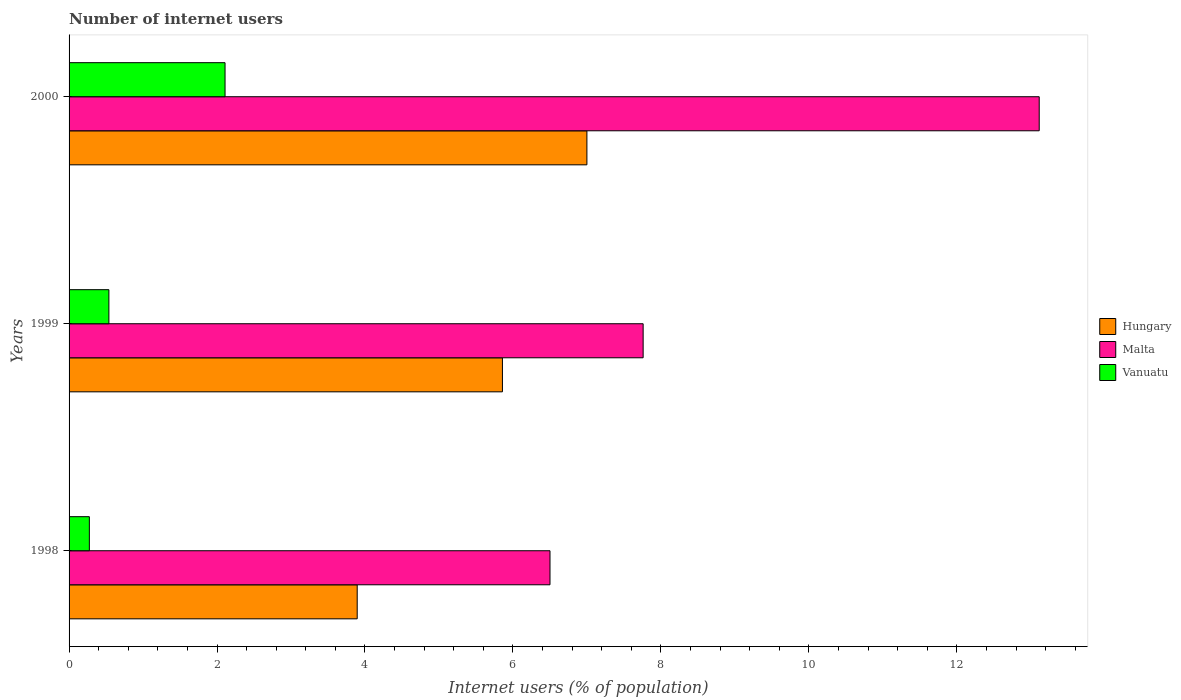How many different coloured bars are there?
Your answer should be very brief. 3. How many groups of bars are there?
Provide a succinct answer. 3. Are the number of bars per tick equal to the number of legend labels?
Give a very brief answer. Yes. How many bars are there on the 1st tick from the top?
Provide a succinct answer. 3. How many bars are there on the 1st tick from the bottom?
Ensure brevity in your answer.  3. What is the label of the 2nd group of bars from the top?
Offer a very short reply. 1999. In how many cases, is the number of bars for a given year not equal to the number of legend labels?
Keep it short and to the point. 0. What is the number of internet users in Vanuatu in 1999?
Make the answer very short. 0.54. Across all years, what is the maximum number of internet users in Hungary?
Your response must be concise. 7. Across all years, what is the minimum number of internet users in Vanuatu?
Provide a succinct answer. 0.27. In which year was the number of internet users in Vanuatu maximum?
Provide a short and direct response. 2000. In which year was the number of internet users in Malta minimum?
Offer a very short reply. 1998. What is the total number of internet users in Hungary in the graph?
Give a very brief answer. 16.75. What is the difference between the number of internet users in Vanuatu in 1999 and that in 2000?
Ensure brevity in your answer.  -1.57. What is the difference between the number of internet users in Malta in 2000 and the number of internet users in Hungary in 1998?
Provide a succinct answer. 9.22. What is the average number of internet users in Hungary per year?
Give a very brief answer. 5.58. In the year 1999, what is the difference between the number of internet users in Malta and number of internet users in Hungary?
Ensure brevity in your answer.  1.9. What is the ratio of the number of internet users in Hungary in 1999 to that in 2000?
Provide a short and direct response. 0.84. Is the number of internet users in Vanuatu in 1998 less than that in 1999?
Your answer should be very brief. Yes. Is the difference between the number of internet users in Malta in 1999 and 2000 greater than the difference between the number of internet users in Hungary in 1999 and 2000?
Your answer should be compact. No. What is the difference between the highest and the second highest number of internet users in Vanuatu?
Offer a very short reply. 1.57. What is the difference between the highest and the lowest number of internet users in Malta?
Offer a very short reply. 6.61. What does the 3rd bar from the top in 2000 represents?
Your answer should be very brief. Hungary. What does the 3rd bar from the bottom in 2000 represents?
Give a very brief answer. Vanuatu. Are all the bars in the graph horizontal?
Keep it short and to the point. Yes. What is the difference between two consecutive major ticks on the X-axis?
Keep it short and to the point. 2. Does the graph contain any zero values?
Offer a very short reply. No. Where does the legend appear in the graph?
Ensure brevity in your answer.  Center right. How many legend labels are there?
Your answer should be compact. 3. What is the title of the graph?
Offer a terse response. Number of internet users. Does "Lao PDR" appear as one of the legend labels in the graph?
Provide a short and direct response. No. What is the label or title of the X-axis?
Offer a very short reply. Internet users (% of population). What is the label or title of the Y-axis?
Your answer should be very brief. Years. What is the Internet users (% of population) of Hungary in 1998?
Keep it short and to the point. 3.89. What is the Internet users (% of population) of Malta in 1998?
Your response must be concise. 6.5. What is the Internet users (% of population) of Vanuatu in 1998?
Ensure brevity in your answer.  0.27. What is the Internet users (% of population) in Hungary in 1999?
Provide a succinct answer. 5.86. What is the Internet users (% of population) in Malta in 1999?
Your response must be concise. 7.76. What is the Internet users (% of population) of Vanuatu in 1999?
Provide a short and direct response. 0.54. What is the Internet users (% of population) in Hungary in 2000?
Make the answer very short. 7. What is the Internet users (% of population) in Malta in 2000?
Make the answer very short. 13.11. What is the Internet users (% of population) in Vanuatu in 2000?
Give a very brief answer. 2.11. Across all years, what is the maximum Internet users (% of population) in Hungary?
Give a very brief answer. 7. Across all years, what is the maximum Internet users (% of population) in Malta?
Keep it short and to the point. 13.11. Across all years, what is the maximum Internet users (% of population) in Vanuatu?
Your response must be concise. 2.11. Across all years, what is the minimum Internet users (% of population) in Hungary?
Your answer should be compact. 3.89. Across all years, what is the minimum Internet users (% of population) of Malta?
Your answer should be compact. 6.5. Across all years, what is the minimum Internet users (% of population) of Vanuatu?
Ensure brevity in your answer.  0.27. What is the total Internet users (% of population) in Hungary in the graph?
Provide a succinct answer. 16.75. What is the total Internet users (% of population) of Malta in the graph?
Your response must be concise. 27.37. What is the total Internet users (% of population) in Vanuatu in the graph?
Your response must be concise. 2.92. What is the difference between the Internet users (% of population) in Hungary in 1998 and that in 1999?
Provide a short and direct response. -1.96. What is the difference between the Internet users (% of population) of Malta in 1998 and that in 1999?
Your answer should be very brief. -1.26. What is the difference between the Internet users (% of population) of Vanuatu in 1998 and that in 1999?
Your answer should be compact. -0.26. What is the difference between the Internet users (% of population) in Hungary in 1998 and that in 2000?
Your answer should be very brief. -3.1. What is the difference between the Internet users (% of population) of Malta in 1998 and that in 2000?
Keep it short and to the point. -6.61. What is the difference between the Internet users (% of population) of Vanuatu in 1998 and that in 2000?
Offer a very short reply. -1.83. What is the difference between the Internet users (% of population) in Hungary in 1999 and that in 2000?
Ensure brevity in your answer.  -1.14. What is the difference between the Internet users (% of population) in Malta in 1999 and that in 2000?
Ensure brevity in your answer.  -5.35. What is the difference between the Internet users (% of population) in Vanuatu in 1999 and that in 2000?
Make the answer very short. -1.57. What is the difference between the Internet users (% of population) in Hungary in 1998 and the Internet users (% of population) in Malta in 1999?
Your answer should be compact. -3.87. What is the difference between the Internet users (% of population) of Hungary in 1998 and the Internet users (% of population) of Vanuatu in 1999?
Provide a short and direct response. 3.36. What is the difference between the Internet users (% of population) in Malta in 1998 and the Internet users (% of population) in Vanuatu in 1999?
Provide a short and direct response. 5.96. What is the difference between the Internet users (% of population) of Hungary in 1998 and the Internet users (% of population) of Malta in 2000?
Your answer should be very brief. -9.22. What is the difference between the Internet users (% of population) of Hungary in 1998 and the Internet users (% of population) of Vanuatu in 2000?
Provide a succinct answer. 1.79. What is the difference between the Internet users (% of population) in Malta in 1998 and the Internet users (% of population) in Vanuatu in 2000?
Your response must be concise. 4.39. What is the difference between the Internet users (% of population) of Hungary in 1999 and the Internet users (% of population) of Malta in 2000?
Provide a short and direct response. -7.26. What is the difference between the Internet users (% of population) of Hungary in 1999 and the Internet users (% of population) of Vanuatu in 2000?
Your answer should be compact. 3.75. What is the difference between the Internet users (% of population) in Malta in 1999 and the Internet users (% of population) in Vanuatu in 2000?
Your answer should be very brief. 5.65. What is the average Internet users (% of population) of Hungary per year?
Keep it short and to the point. 5.58. What is the average Internet users (% of population) in Malta per year?
Make the answer very short. 9.12. What is the average Internet users (% of population) in Vanuatu per year?
Offer a very short reply. 0.97. In the year 1998, what is the difference between the Internet users (% of population) of Hungary and Internet users (% of population) of Malta?
Provide a succinct answer. -2.61. In the year 1998, what is the difference between the Internet users (% of population) in Hungary and Internet users (% of population) in Vanuatu?
Offer a very short reply. 3.62. In the year 1998, what is the difference between the Internet users (% of population) of Malta and Internet users (% of population) of Vanuatu?
Provide a succinct answer. 6.23. In the year 1999, what is the difference between the Internet users (% of population) in Hungary and Internet users (% of population) in Malta?
Keep it short and to the point. -1.9. In the year 1999, what is the difference between the Internet users (% of population) in Hungary and Internet users (% of population) in Vanuatu?
Your response must be concise. 5.32. In the year 1999, what is the difference between the Internet users (% of population) of Malta and Internet users (% of population) of Vanuatu?
Keep it short and to the point. 7.22. In the year 2000, what is the difference between the Internet users (% of population) in Hungary and Internet users (% of population) in Malta?
Provide a short and direct response. -6.11. In the year 2000, what is the difference between the Internet users (% of population) in Hungary and Internet users (% of population) in Vanuatu?
Provide a succinct answer. 4.89. In the year 2000, what is the difference between the Internet users (% of population) of Malta and Internet users (% of population) of Vanuatu?
Provide a short and direct response. 11.01. What is the ratio of the Internet users (% of population) of Hungary in 1998 to that in 1999?
Keep it short and to the point. 0.66. What is the ratio of the Internet users (% of population) in Malta in 1998 to that in 1999?
Offer a very short reply. 0.84. What is the ratio of the Internet users (% of population) in Vanuatu in 1998 to that in 1999?
Provide a short and direct response. 0.51. What is the ratio of the Internet users (% of population) in Hungary in 1998 to that in 2000?
Your answer should be very brief. 0.56. What is the ratio of the Internet users (% of population) of Malta in 1998 to that in 2000?
Offer a terse response. 0.5. What is the ratio of the Internet users (% of population) of Vanuatu in 1998 to that in 2000?
Give a very brief answer. 0.13. What is the ratio of the Internet users (% of population) of Hungary in 1999 to that in 2000?
Offer a terse response. 0.84. What is the ratio of the Internet users (% of population) of Malta in 1999 to that in 2000?
Provide a succinct answer. 0.59. What is the ratio of the Internet users (% of population) of Vanuatu in 1999 to that in 2000?
Give a very brief answer. 0.26. What is the difference between the highest and the second highest Internet users (% of population) of Hungary?
Your response must be concise. 1.14. What is the difference between the highest and the second highest Internet users (% of population) in Malta?
Your answer should be very brief. 5.35. What is the difference between the highest and the second highest Internet users (% of population) of Vanuatu?
Give a very brief answer. 1.57. What is the difference between the highest and the lowest Internet users (% of population) in Hungary?
Provide a succinct answer. 3.1. What is the difference between the highest and the lowest Internet users (% of population) of Malta?
Offer a terse response. 6.61. What is the difference between the highest and the lowest Internet users (% of population) in Vanuatu?
Give a very brief answer. 1.83. 